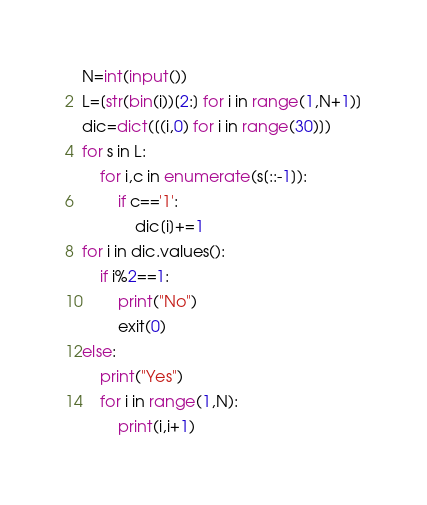Convert code to text. <code><loc_0><loc_0><loc_500><loc_500><_Python_>N=int(input())
L=[str(bin(i))[2:] for i in range(1,N+1)]
dic=dict([(i,0) for i in range(30)])
for s in L:
    for i,c in enumerate(s[::-1]):
        if c=='1':
            dic[i]+=1
for i in dic.values():
    if i%2==1:
        print("No")
        exit(0)
else:
    print("Yes")
    for i in range(1,N):
        print(i,i+1)

</code> 